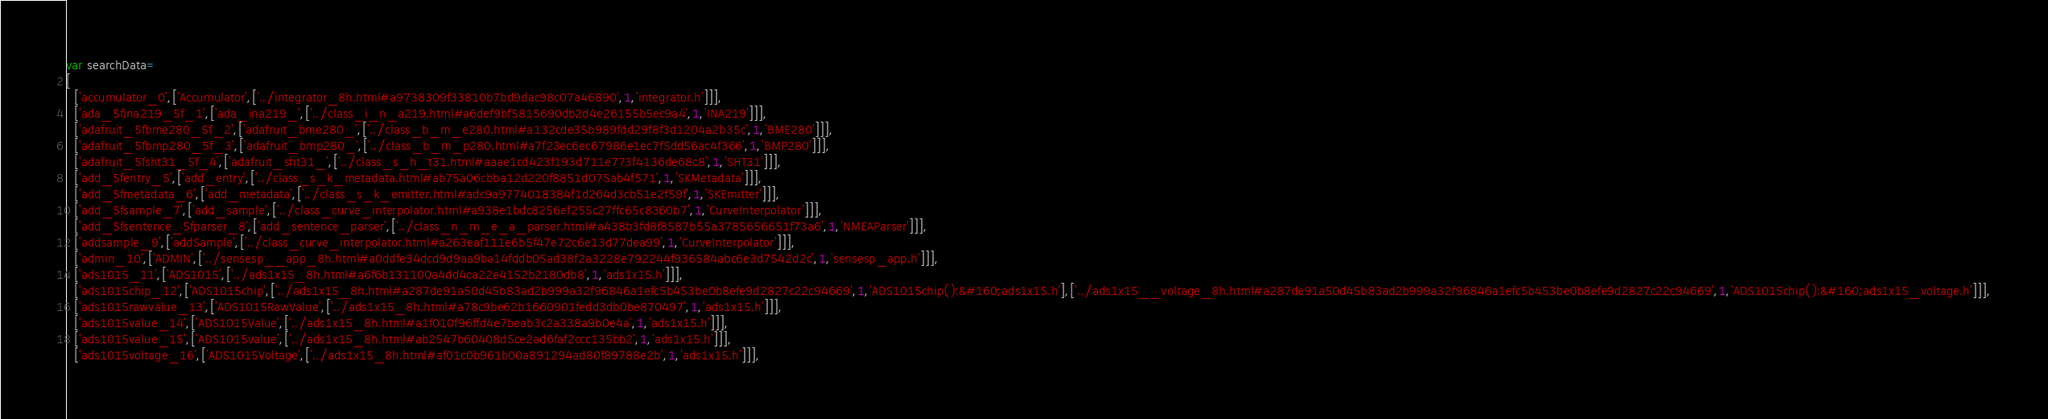<code> <loc_0><loc_0><loc_500><loc_500><_JavaScript_>var searchData=
[
  ['accumulator_0',['Accumulator',['../integrator_8h.html#a9738309f33810b7bd9dac98c07a46890',1,'integrator.h']]],
  ['ada_5fina219_5f_1',['ada_ina219_',['../class_i_n_a219.html#a6def9bf5815690db2d4e26155b5ec9a4',1,'INA219']]],
  ['adafruit_5fbme280_5f_2',['adafruit_bme280_',['../class_b_m_e280.html#a132cde35b989fdd29f8f3d1204a2b35c',1,'BME280']]],
  ['adafruit_5fbmp280_5f_3',['adafruit_bmp280_',['../class_b_m_p280.html#a7f23ec6ec67986e1ec7f5dd56ac4f366',1,'BMP280']]],
  ['adafruit_5fsht31_5f_4',['adafruit_sht31_',['../class_s_h_t31.html#aaae1cd423f193d711e773f4136de68c8',1,'SHT31']]],
  ['add_5fentry_5',['add_entry',['../class_s_k_metadata.html#ab75a06cbba12d220f8851d075ab4f571',1,'SKMetadata']]],
  ['add_5fmetadata_6',['add_metadata',['../class_s_k_emitter.html#adc9a9774018384f1d264d3cb51e2f59f',1,'SKEmitter']]],
  ['add_5fsample_7',['add_sample',['../class_curve_interpolator.html#a938e1bdc8256ef255c27ffc65c8360b7',1,'CurveInterpolator']]],
  ['add_5fsentence_5fparser_8',['add_sentence_parser',['../class_n_m_e_a_parser.html#a438b3fd8f8587b55a3785656651f73a6',1,'NMEAParser']]],
  ['addsample_9',['addSample',['../class_curve_interpolator.html#a263eaf111e6b5f47e72c6e13d77dea99',1,'CurveInterpolator']]],
  ['admin_10',['ADMIN',['../sensesp__app_8h.html#a0ddfe34dcd9d9aa9ba14fddb05ad38f2a3228e792244f936584abc6e3d7542d2c',1,'sensesp_app.h']]],
  ['ads1015_11',['ADS1015',['../ads1x15_8h.html#a6f6b131100a4dd4ca22e4152b2180db8',1,'ads1x15.h']]],
  ['ads1015chip_12',['ADS1015chip',['../ads1x15_8h.html#a287de91a50d45b83ad2b999a32f96846a1efc5b453be0b8efe9d2827c22c94669',1,'ADS1015chip():&#160;ads1x15.h'],['../ads1x15__voltage_8h.html#a287de91a50d45b83ad2b999a32f96846a1efc5b453be0b8efe9d2827c22c94669',1,'ADS1015chip():&#160;ads1x15_voltage.h']]],
  ['ads1015rawvalue_13',['ADS1015RawValue',['../ads1x15_8h.html#a78c9be62b1660901fedd3db0be870497',1,'ads1x15.h']]],
  ['ads1015value_14',['ADS1015Value',['../ads1x15_8h.html#a1f010f96ffd4e7beab3c2a338a9b0e4a',1,'ads1x15.h']]],
  ['ads1015value_15',['ADS1015value',['../ads1x15_8h.html#ab2547b60408d5ce2ad6faf2ccc135bb2',1,'ads1x15.h']]],
  ['ads1015voltage_16',['ADS1015Voltage',['../ads1x15_8h.html#af01c0b961b00a891294ad80f89788e2b',1,'ads1x15.h']]],</code> 